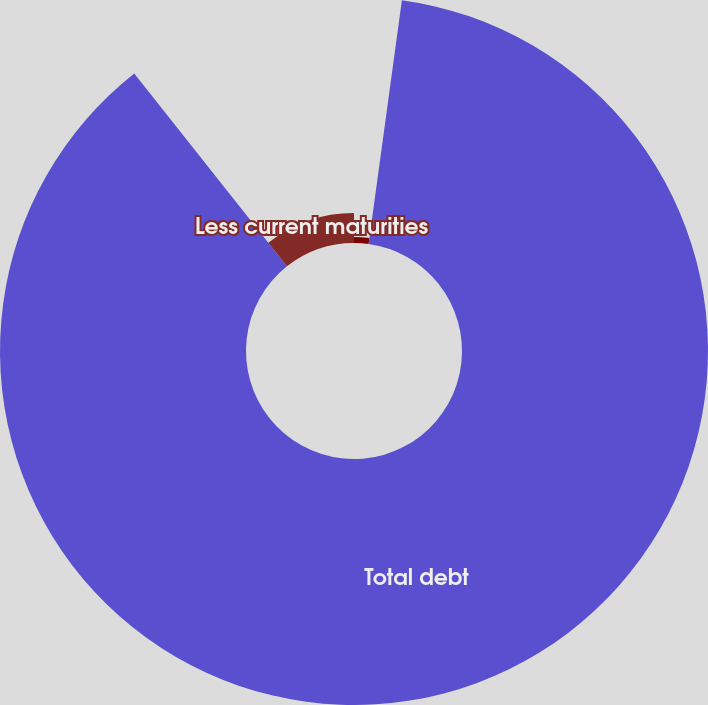Convert chart. <chart><loc_0><loc_0><loc_500><loc_500><pie_chart><fcel>Other<fcel>Total debt<fcel>Less current maturities<nl><fcel>2.16%<fcel>87.18%<fcel>10.66%<nl></chart> 